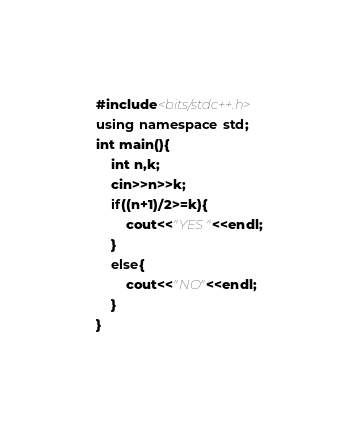Convert code to text. <code><loc_0><loc_0><loc_500><loc_500><_C++_>#include<bits/stdc++.h>
using namespace std;
int main(){
    int n,k;
    cin>>n>>k;
    if((n+1)/2>=k){
        cout<<"YES"<<endl;
    }
    else{
        cout<<"NO"<<endl;
    }
}</code> 